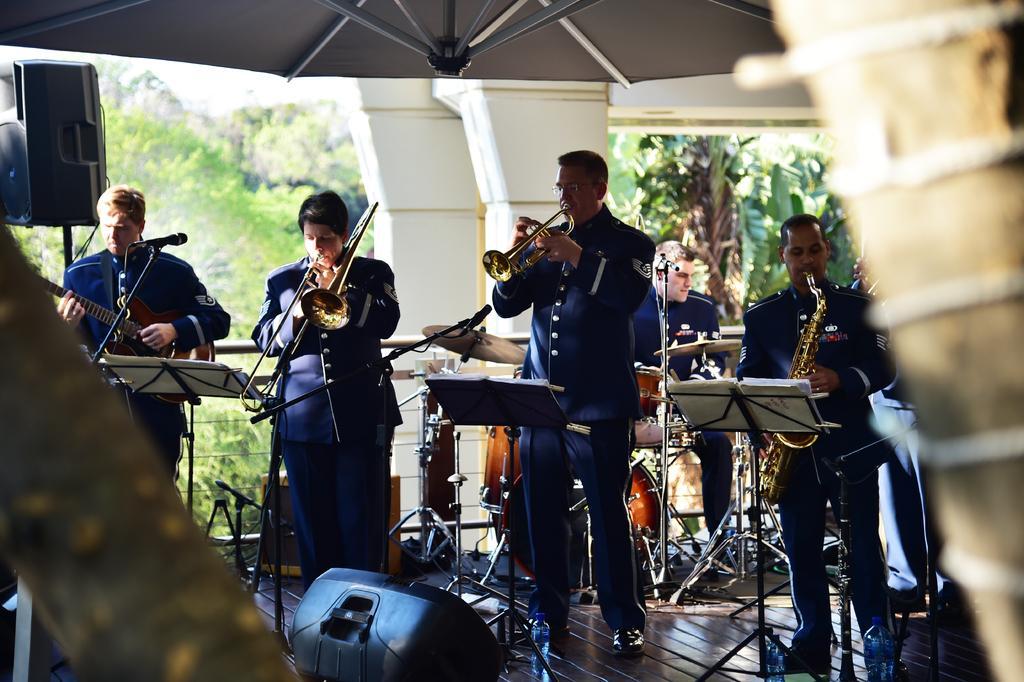Can you describe this image briefly? This picture shows a music band who are playing a different musical instruments in their hands. In front of them, there is a book on the stand. There are some speakers, pillars and some trees in the background. 